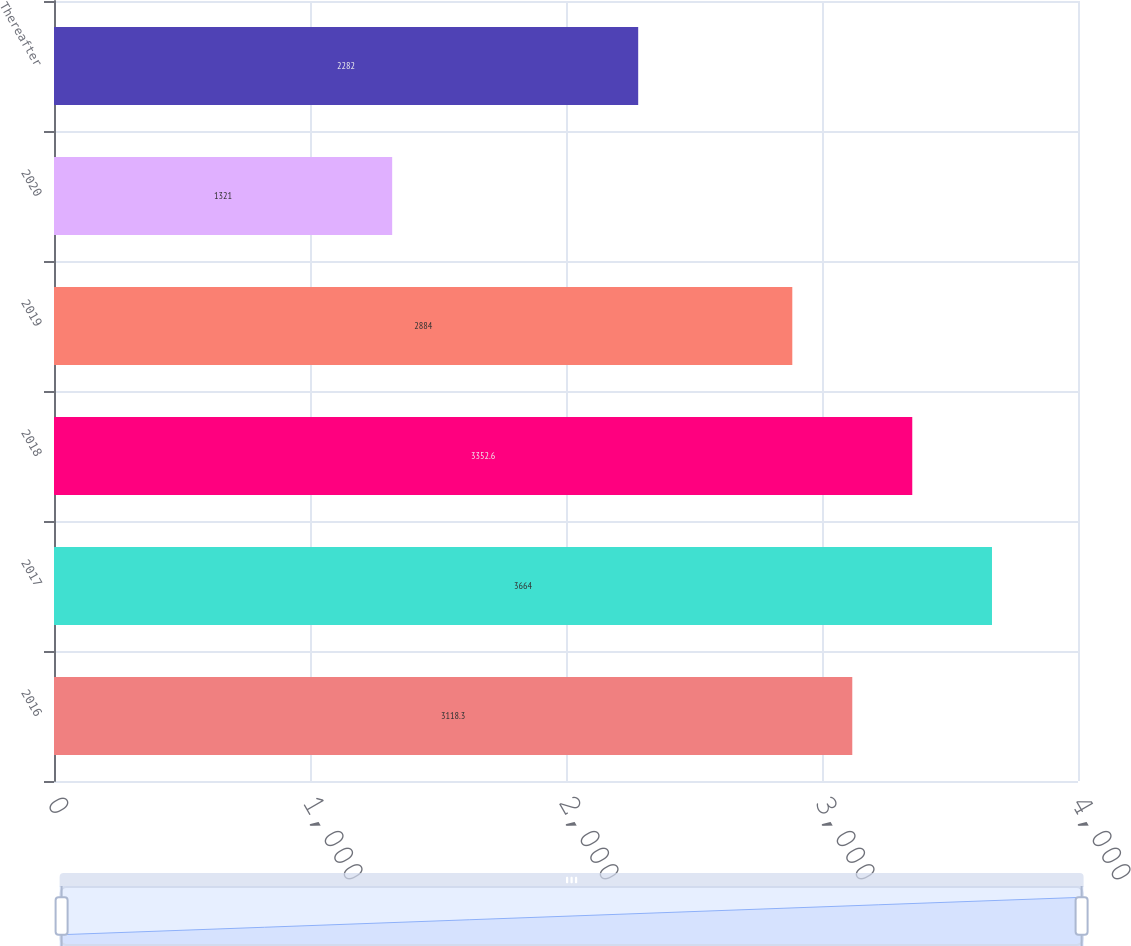Convert chart. <chart><loc_0><loc_0><loc_500><loc_500><bar_chart><fcel>2016<fcel>2017<fcel>2018<fcel>2019<fcel>2020<fcel>Thereafter<nl><fcel>3118.3<fcel>3664<fcel>3352.6<fcel>2884<fcel>1321<fcel>2282<nl></chart> 